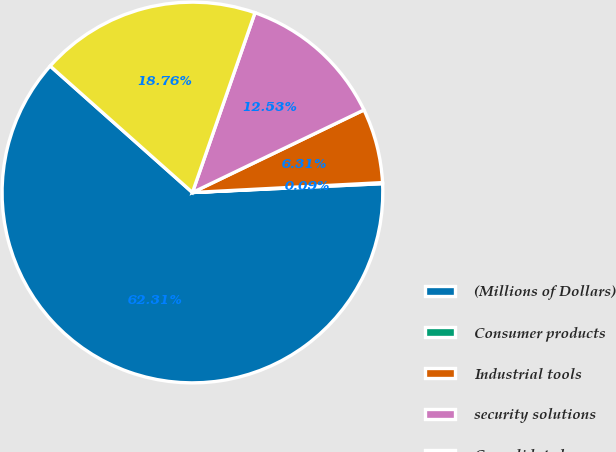<chart> <loc_0><loc_0><loc_500><loc_500><pie_chart><fcel>(Millions of Dollars)<fcel>Consumer products<fcel>Industrial tools<fcel>security solutions<fcel>Consolidated<nl><fcel>62.3%<fcel>0.09%<fcel>6.31%<fcel>12.53%<fcel>18.76%<nl></chart> 